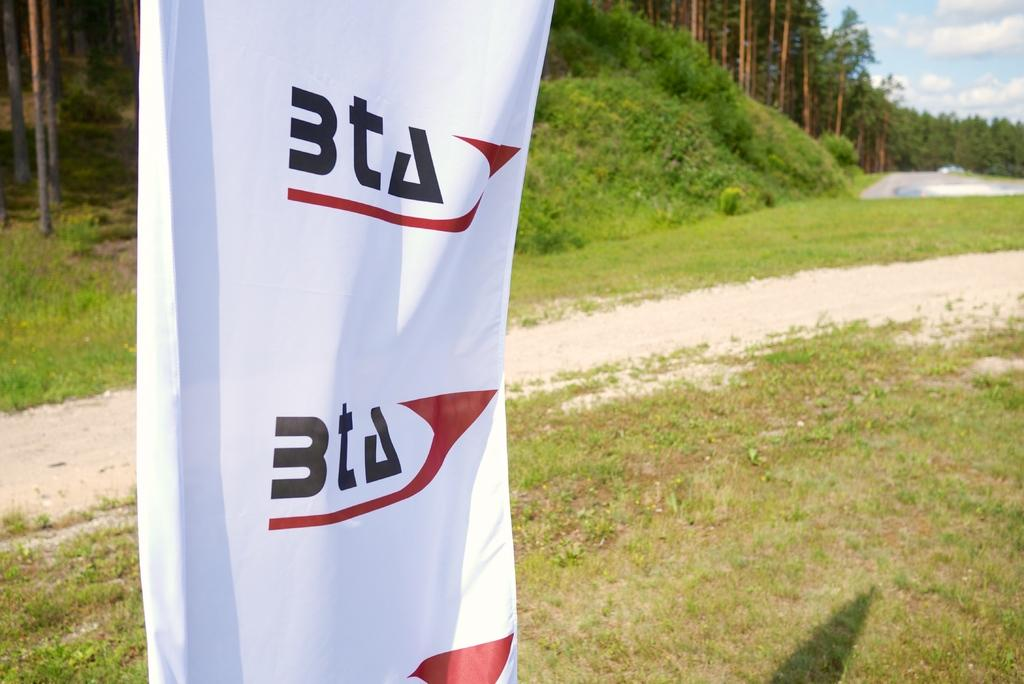What is featured on the banner in the image? There is a banner with text in the image. What can be seen in the background of the image? There are trees and the sky visible in the background of the image. How many times does the dad sing the song in the image? There is no dad or song present in the image, so it is not possible to answer that question. 